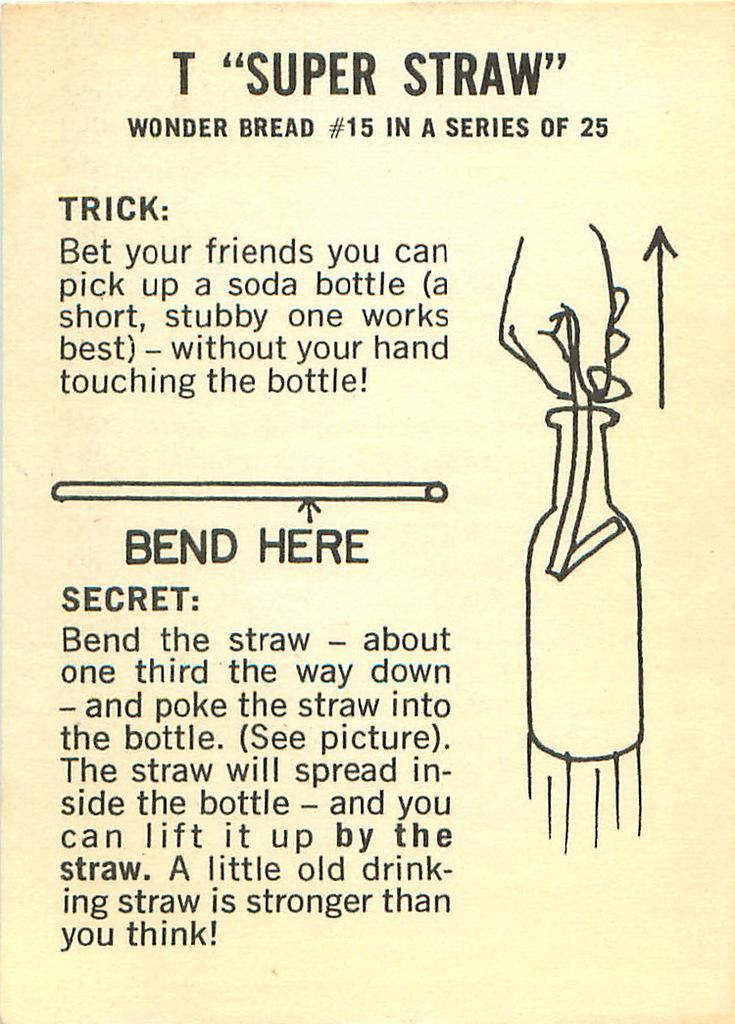<image>
Write a terse but informative summary of the picture. a page that is titled 't "super straw" wonder bread #15 in a series of 25' 